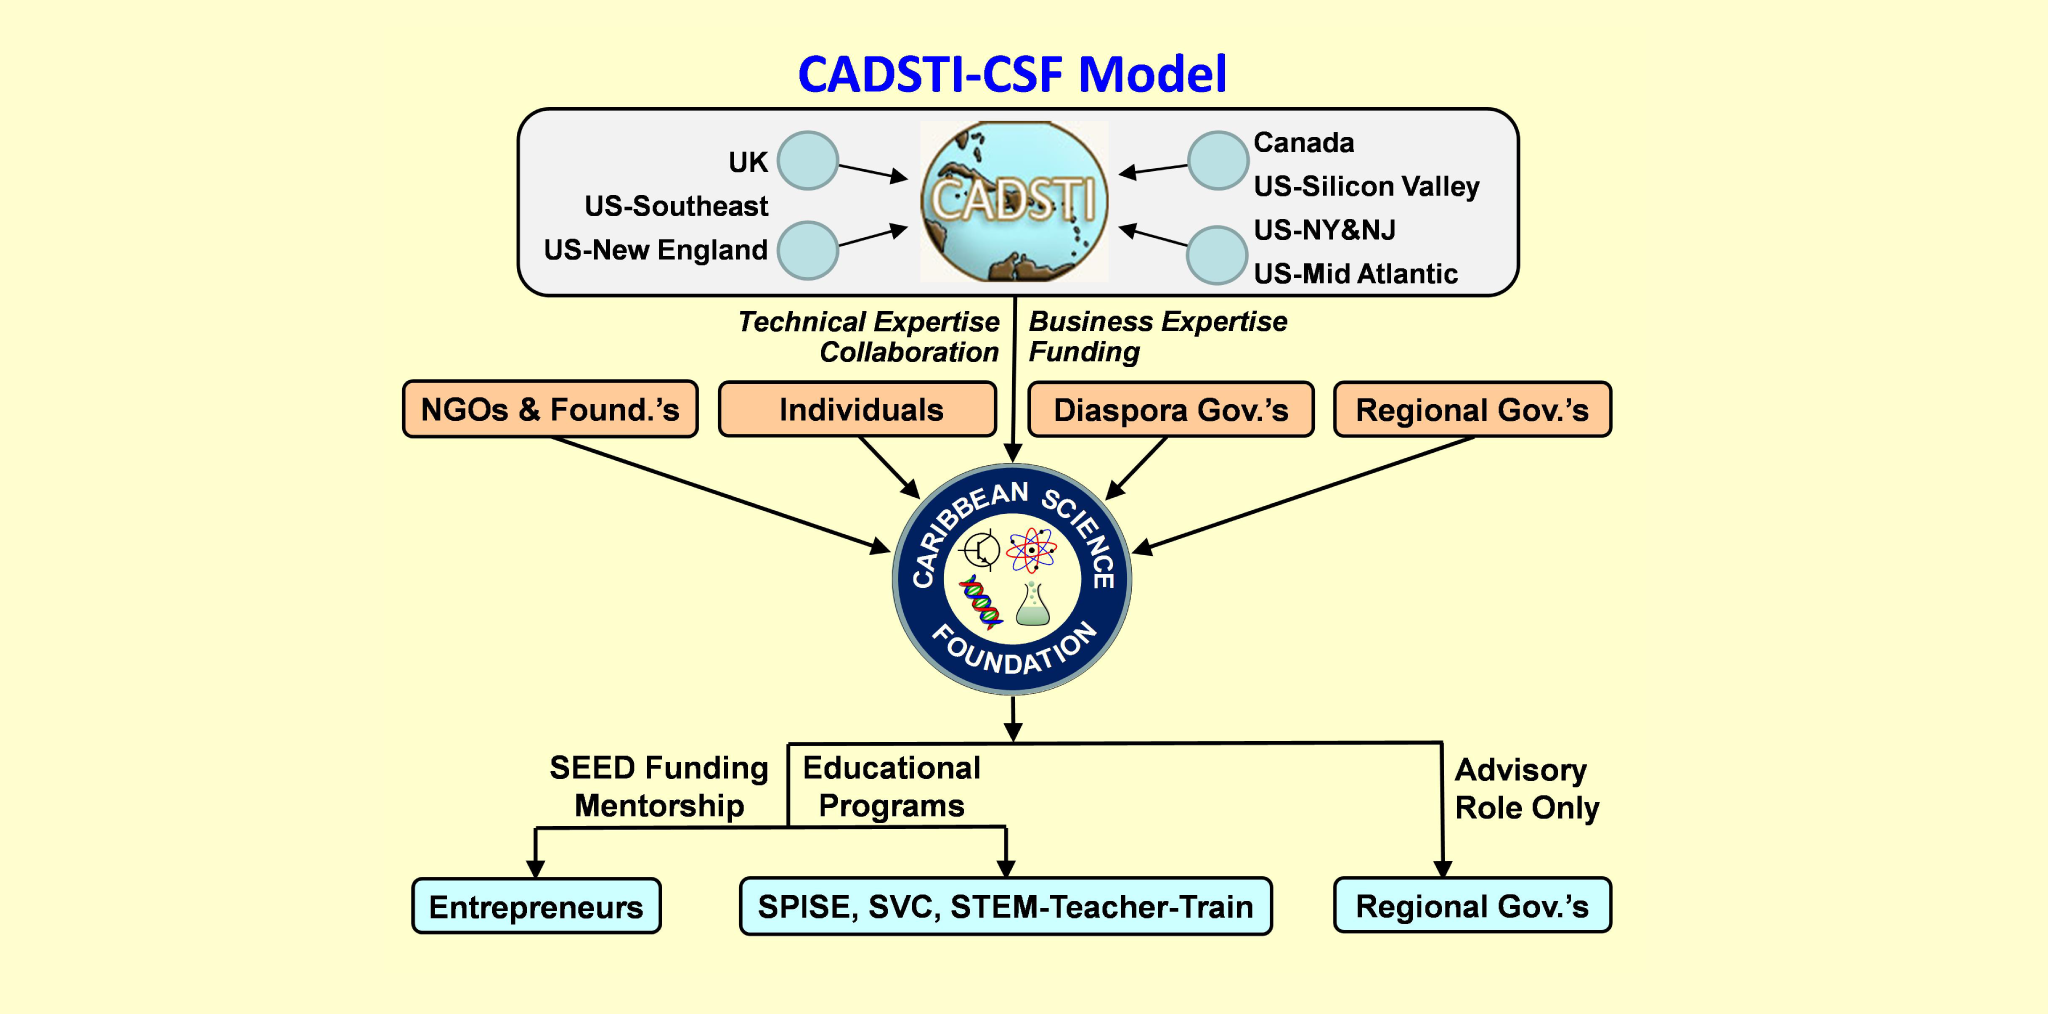How does the participation of NGOs and individual sponsors in the Caribbean Science Foundation's model contribute to its objectives? NGOs and individual sponsors play a crucial role in the Caribbean Science Foundation’s model by providing both financial support and expertise. Their involvement enables the foundation to fund educational programs, mentorship initiatives, and support services for entrepreneurs. Additionally, these sponsors often bring a wealth of experience and networks that can be leveraged to foster growth and innovation in the science and technology sectors of the Caribbean. Can you provide an example of how an NGO might influence a specific educational program supported by the Caribbean Science Foundation? Certainly! For instance, an NGO focused on environmental conservation might collaborate with the CSF to develop a specialized curriculum within the SPISE program. This curriculum could include modules on sustainable practices, renewable energy, and environmental science, thereby equipping students with the knowledge and skills to tackle environmental challenges. The NGO might also offer internships or real-world project opportunities, giving students practical experience and exposure to the field. 